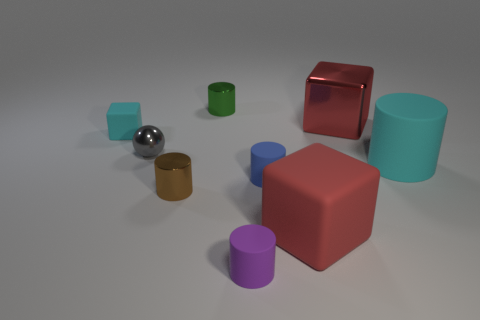What shape is the big red object in front of the red thing that is on the right side of the large red rubber object?
Offer a very short reply. Cube. Is there anything else that is the same color as the metal cube?
Keep it short and to the point. Yes. There is a gray sphere; is its size the same as the block left of the tiny purple matte object?
Provide a succinct answer. Yes. What number of small objects are yellow cylinders or red matte blocks?
Your answer should be very brief. 0. Is the number of big green spheres greater than the number of gray metal spheres?
Your answer should be compact. No. How many small green cylinders are on the left side of the matte cube that is left of the red block in front of the large red metal cube?
Your answer should be very brief. 0. What is the shape of the tiny blue thing?
Provide a short and direct response. Cylinder. What number of other objects are there of the same material as the tiny brown cylinder?
Provide a succinct answer. 3. Is the size of the gray sphere the same as the cyan cylinder?
Provide a succinct answer. No. What is the shape of the large cyan matte thing in front of the small green metal object?
Your answer should be very brief. Cylinder. 